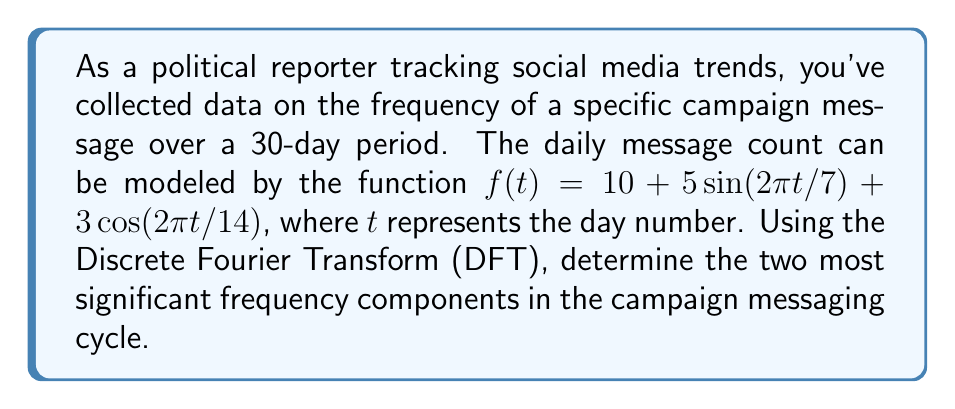Solve this math problem. To solve this problem, we'll follow these steps:

1) First, we need to understand that the Discrete Fourier Transform (DFT) of a signal $x[n]$ of length $N$ is given by:

   $$X[k] = \sum_{n=0}^{N-1} x[n] e^{-j2\pi kn/N}$$

   where $k = 0, 1, ..., N-1$

2) In our case, $N = 30$ (30-day period), and $x[n] = f(n)$ for $n = 0, 1, ..., 29$

3) We don't need to calculate the full DFT manually. Instead, we can analyze the given function:

   $f(t) = 10 + 5\sin(2\pi t/7) + 3\cos(2\pi t/14)$

4) This function has three components:
   - A constant term: 10
   - A sine term with period 7 days: $5\sin(2\pi t/7)$
   - A cosine term with period 14 days: $3\cos(2\pi t/14)$

5) In the frequency domain, these correspond to:
   - The constant term (10) contributes to the DC component (0 frequency)
   - The 7-day cycle corresponds to a frequency of 1/7 cycles per day
   - The 14-day cycle corresponds to a frequency of 1/14 cycles per day

6) The amplitude of each component in the frequency domain is proportional to its coefficient in the time domain function. So, after the DC component, the largest amplitudes will be associated with the 7-day and 14-day cycles.

7) Therefore, the two most significant frequency components are:
   - 1/7 cycles per day (corresponding to the 7-day cycle)
   - 1/14 cycles per day (corresponding to the 14-day cycle)
Answer: The two most significant frequency components in the campaign messaging cycle are 1/7 cycles per day and 1/14 cycles per day. 